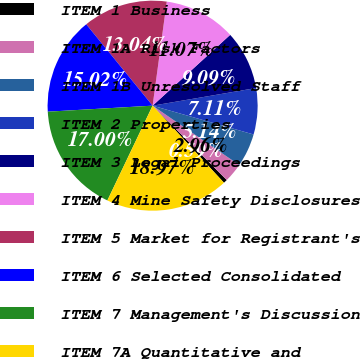Convert chart. <chart><loc_0><loc_0><loc_500><loc_500><pie_chart><fcel>ITEM 1 Business<fcel>ITEM 1A Risk Factors<fcel>ITEM 1B Unresolved Staff<fcel>ITEM 2 Properties<fcel>ITEM 3 Legal Proceedings<fcel>ITEM 4 Mine Safety Disclosures<fcel>ITEM 5 Market for Registrant's<fcel>ITEM 6 Selected Consolidated<fcel>ITEM 7 Management's Discussion<fcel>ITEM 7A Quantitative and<nl><fcel>0.59%<fcel>2.96%<fcel>5.14%<fcel>7.11%<fcel>9.09%<fcel>11.07%<fcel>13.04%<fcel>15.02%<fcel>17.0%<fcel>18.97%<nl></chart> 